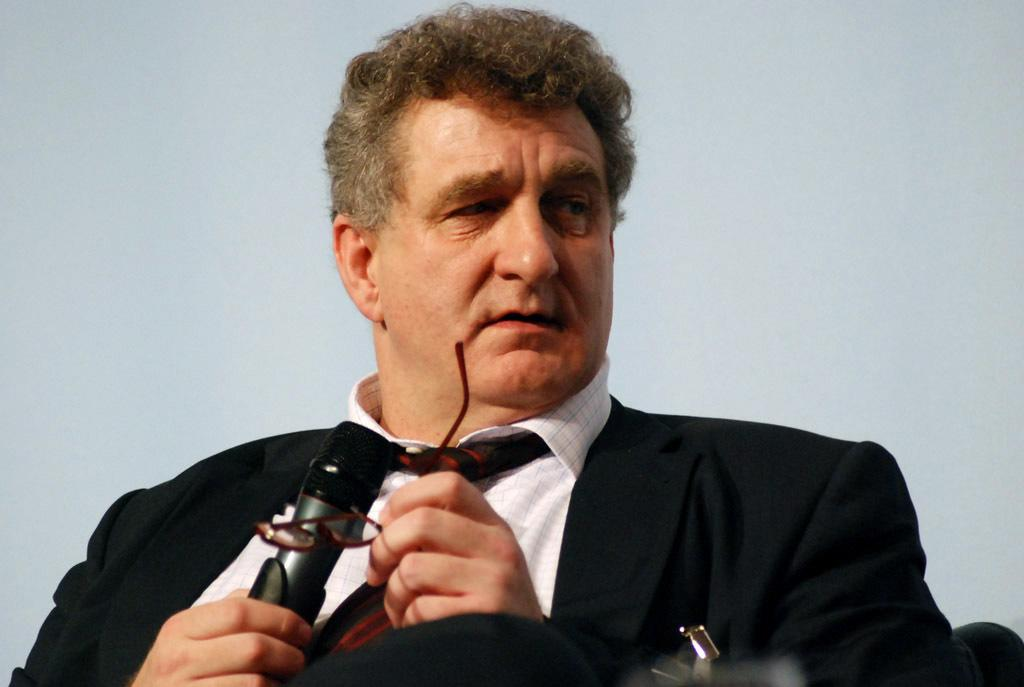What is the main subject of the image? There is a person in the image. What is the person wearing? The person is wearing a black suit. What is the person holding in the image? The person is holding a microphone. What type of eyewear is the person wearing? The person is wearing spectacles. What is the person doing with the spectacles? The spectacles are in the person's hands. What type of zipper can be seen on the plate in the image? There is no plate or zipper present in the image. What expertise does the person in the image have? The image does not provide any information about the person's expertise. 